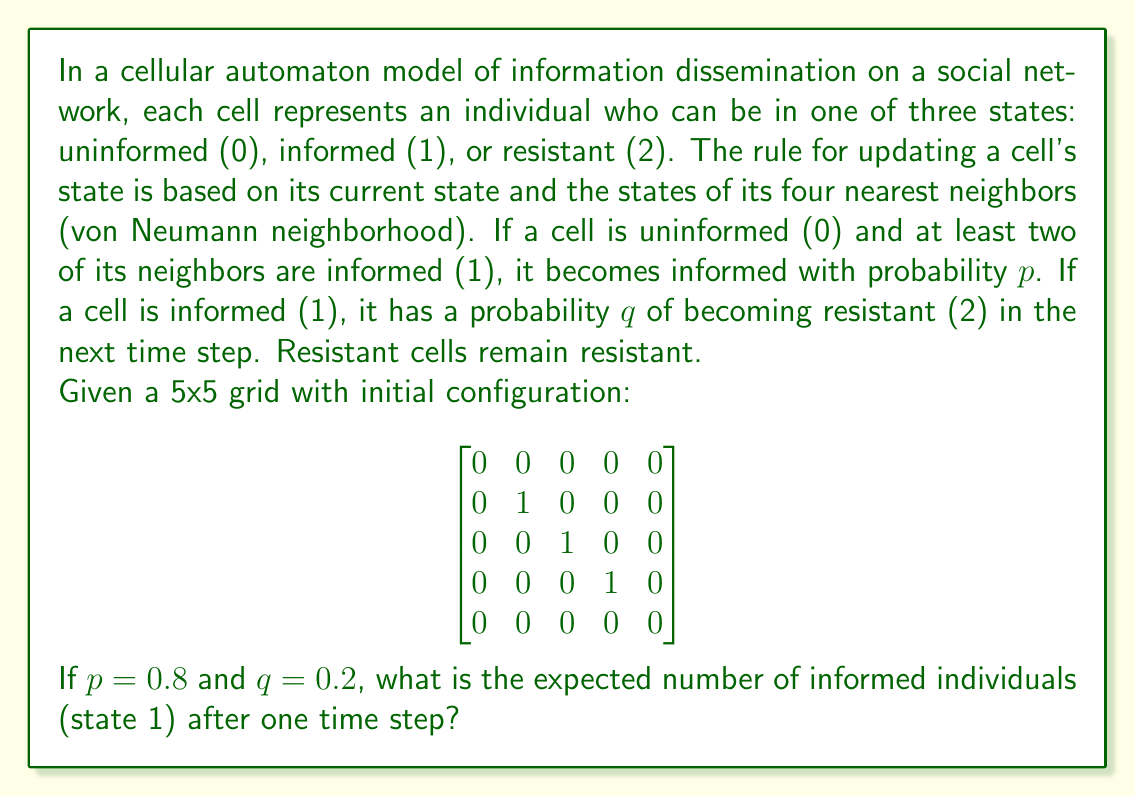Could you help me with this problem? To solve this problem, we need to analyze the state of each cell after one time step:

1) First, identify cells that could potentially change state:
   - Uninformed cells (0) with at least two informed neighbors could become informed.
   - Informed cells (1) could become resistant.

2) There are three informed cells initially. Each has a 0.2 probability of becoming resistant:
   Expected number of original informed cells remaining = $3 \times (1 - 0.2) = 2.4$

3) Now, examine uninformed cells that could become informed:
   - Cell (1,1) has two informed neighbors. P(becoming informed) = 0.8
   - Cell (1,3) has two informed neighbors. P(becoming informed) = 0.8
   - Cell (3,3) has two informed neighbors. P(becoming informed) = 0.8

4) Calculate the expected number of newly informed cells:
   Expected new informed cells = $3 \times 0.8 = 2.4$

5) Sum the expected number of original informed cells remaining and newly informed cells:
   Total expected informed cells = $2.4 + 2.4 = 4.8$

This result reflects the dynamic nature of information spread in social networks, accounting for both information adoption and resistance.
Answer: 4.8 